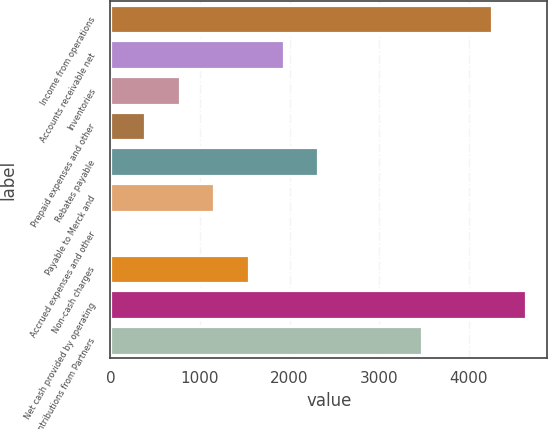Convert chart to OTSL. <chart><loc_0><loc_0><loc_500><loc_500><bar_chart><fcel>Income from operations<fcel>Accounts receivable net<fcel>Inventories<fcel>Prepaid expenses and other<fcel>Rebates payable<fcel>Payable to Merck and<fcel>Accrued expenses and other<fcel>Non-cash charges<fcel>Net cash provided by operating<fcel>Contributions from Partners<nl><fcel>4254.7<fcel>1934.5<fcel>774.4<fcel>387.7<fcel>2321.2<fcel>1161.1<fcel>1<fcel>1547.8<fcel>4641.4<fcel>3481.3<nl></chart> 